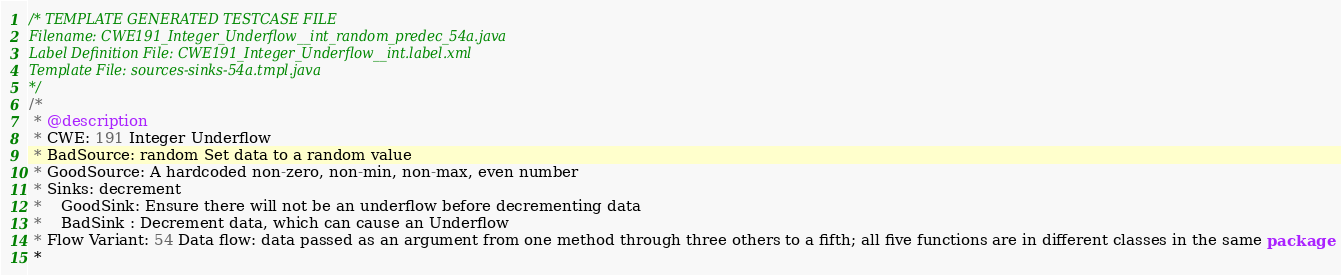<code> <loc_0><loc_0><loc_500><loc_500><_Java_>/* TEMPLATE GENERATED TESTCASE FILE
Filename: CWE191_Integer_Underflow__int_random_predec_54a.java
Label Definition File: CWE191_Integer_Underflow__int.label.xml
Template File: sources-sinks-54a.tmpl.java
*/
/*
 * @description
 * CWE: 191 Integer Underflow
 * BadSource: random Set data to a random value
 * GoodSource: A hardcoded non-zero, non-min, non-max, even number
 * Sinks: decrement
 *    GoodSink: Ensure there will not be an underflow before decrementing data
 *    BadSink : Decrement data, which can cause an Underflow
 * Flow Variant: 54 Data flow: data passed as an argument from one method through three others to a fifth; all five functions are in different classes in the same package
 *</code> 